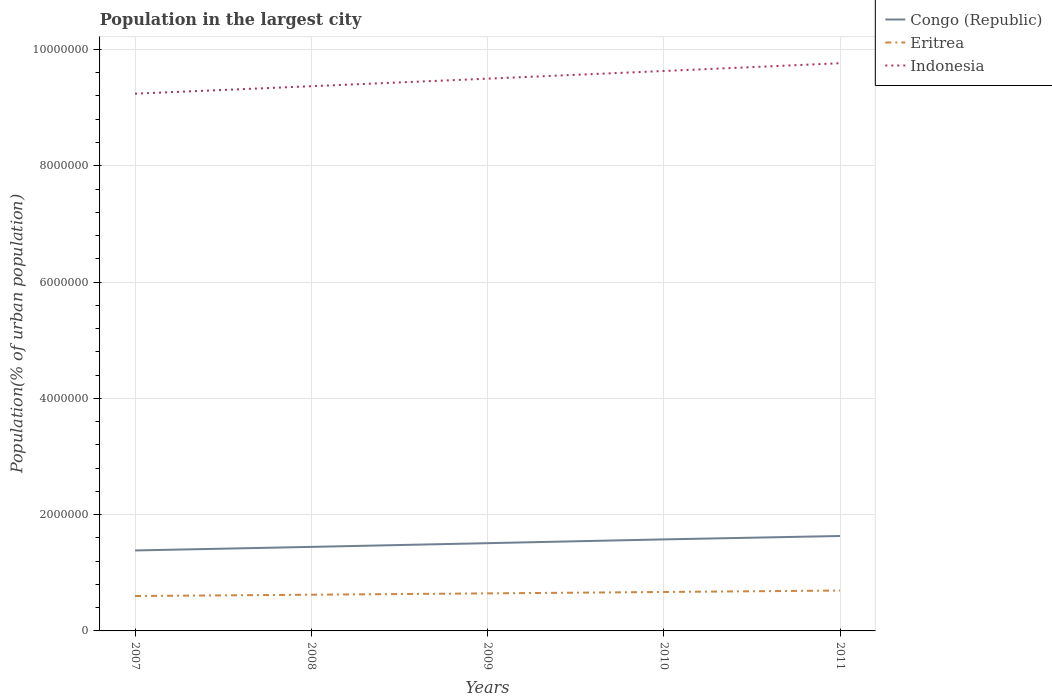Does the line corresponding to Congo (Republic) intersect with the line corresponding to Indonesia?
Provide a succinct answer. No. Across all years, what is the maximum population in the largest city in Congo (Republic)?
Provide a short and direct response. 1.38e+06. What is the total population in the largest city in Congo (Republic) in the graph?
Keep it short and to the point. -1.87e+05. What is the difference between the highest and the second highest population in the largest city in Indonesia?
Your answer should be very brief. 5.24e+05. How many lines are there?
Give a very brief answer. 3. How many years are there in the graph?
Provide a short and direct response. 5. What is the difference between two consecutive major ticks on the Y-axis?
Make the answer very short. 2.00e+06. Are the values on the major ticks of Y-axis written in scientific E-notation?
Give a very brief answer. No. Does the graph contain any zero values?
Offer a terse response. No. Where does the legend appear in the graph?
Provide a short and direct response. Top right. How many legend labels are there?
Your answer should be very brief. 3. What is the title of the graph?
Offer a very short reply. Population in the largest city. Does "Albania" appear as one of the legend labels in the graph?
Make the answer very short. No. What is the label or title of the Y-axis?
Provide a succinct answer. Population(% of urban population). What is the Population(% of urban population) in Congo (Republic) in 2007?
Your answer should be very brief. 1.38e+06. What is the Population(% of urban population) in Eritrea in 2007?
Give a very brief answer. 6.00e+05. What is the Population(% of urban population) in Indonesia in 2007?
Your response must be concise. 9.24e+06. What is the Population(% of urban population) in Congo (Republic) in 2008?
Your response must be concise. 1.45e+06. What is the Population(% of urban population) of Eritrea in 2008?
Your answer should be compact. 6.23e+05. What is the Population(% of urban population) in Indonesia in 2008?
Provide a succinct answer. 9.37e+06. What is the Population(% of urban population) in Congo (Republic) in 2009?
Ensure brevity in your answer.  1.51e+06. What is the Population(% of urban population) in Eritrea in 2009?
Your answer should be compact. 6.46e+05. What is the Population(% of urban population) in Indonesia in 2009?
Offer a terse response. 9.50e+06. What is the Population(% of urban population) of Congo (Republic) in 2010?
Your response must be concise. 1.57e+06. What is the Population(% of urban population) in Eritrea in 2010?
Your response must be concise. 6.70e+05. What is the Population(% of urban population) in Indonesia in 2010?
Keep it short and to the point. 9.63e+06. What is the Population(% of urban population) in Congo (Republic) in 2011?
Make the answer very short. 1.63e+06. What is the Population(% of urban population) in Eritrea in 2011?
Ensure brevity in your answer.  6.94e+05. What is the Population(% of urban population) in Indonesia in 2011?
Offer a terse response. 9.76e+06. Across all years, what is the maximum Population(% of urban population) in Congo (Republic)?
Your response must be concise. 1.63e+06. Across all years, what is the maximum Population(% of urban population) of Eritrea?
Offer a terse response. 6.94e+05. Across all years, what is the maximum Population(% of urban population) in Indonesia?
Offer a very short reply. 9.76e+06. Across all years, what is the minimum Population(% of urban population) of Congo (Republic)?
Keep it short and to the point. 1.38e+06. Across all years, what is the minimum Population(% of urban population) of Eritrea?
Ensure brevity in your answer.  6.00e+05. Across all years, what is the minimum Population(% of urban population) in Indonesia?
Give a very brief answer. 9.24e+06. What is the total Population(% of urban population) in Congo (Republic) in the graph?
Keep it short and to the point. 7.54e+06. What is the total Population(% of urban population) of Eritrea in the graph?
Provide a short and direct response. 3.23e+06. What is the total Population(% of urban population) in Indonesia in the graph?
Your answer should be compact. 4.75e+07. What is the difference between the Population(% of urban population) in Congo (Republic) in 2007 and that in 2008?
Ensure brevity in your answer.  -6.13e+04. What is the difference between the Population(% of urban population) of Eritrea in 2007 and that in 2008?
Offer a terse response. -2.22e+04. What is the difference between the Population(% of urban population) in Indonesia in 2007 and that in 2008?
Keep it short and to the point. -1.28e+05. What is the difference between the Population(% of urban population) in Congo (Republic) in 2007 and that in 2009?
Ensure brevity in your answer.  -1.25e+05. What is the difference between the Population(% of urban population) in Eritrea in 2007 and that in 2009?
Provide a succinct answer. -4.53e+04. What is the difference between the Population(% of urban population) of Indonesia in 2007 and that in 2009?
Provide a short and direct response. -2.58e+05. What is the difference between the Population(% of urban population) of Congo (Republic) in 2007 and that in 2010?
Provide a short and direct response. -1.90e+05. What is the difference between the Population(% of urban population) of Eritrea in 2007 and that in 2010?
Keep it short and to the point. -6.92e+04. What is the difference between the Population(% of urban population) of Indonesia in 2007 and that in 2010?
Offer a very short reply. -3.90e+05. What is the difference between the Population(% of urban population) of Congo (Republic) in 2007 and that in 2011?
Your response must be concise. -2.49e+05. What is the difference between the Population(% of urban population) in Eritrea in 2007 and that in 2011?
Your answer should be compact. -9.40e+04. What is the difference between the Population(% of urban population) of Indonesia in 2007 and that in 2011?
Your response must be concise. -5.24e+05. What is the difference between the Population(% of urban population) of Congo (Republic) in 2008 and that in 2009?
Offer a terse response. -6.40e+04. What is the difference between the Population(% of urban population) in Eritrea in 2008 and that in 2009?
Offer a very short reply. -2.31e+04. What is the difference between the Population(% of urban population) in Indonesia in 2008 and that in 2009?
Your response must be concise. -1.30e+05. What is the difference between the Population(% of urban population) in Congo (Republic) in 2008 and that in 2010?
Your answer should be compact. -1.29e+05. What is the difference between the Population(% of urban population) of Eritrea in 2008 and that in 2010?
Offer a very short reply. -4.70e+04. What is the difference between the Population(% of urban population) in Indonesia in 2008 and that in 2010?
Keep it short and to the point. -2.62e+05. What is the difference between the Population(% of urban population) in Congo (Republic) in 2008 and that in 2011?
Your response must be concise. -1.87e+05. What is the difference between the Population(% of urban population) in Eritrea in 2008 and that in 2011?
Offer a very short reply. -7.18e+04. What is the difference between the Population(% of urban population) in Indonesia in 2008 and that in 2011?
Ensure brevity in your answer.  -3.95e+05. What is the difference between the Population(% of urban population) of Congo (Republic) in 2009 and that in 2010?
Provide a succinct answer. -6.49e+04. What is the difference between the Population(% of urban population) in Eritrea in 2009 and that in 2010?
Your answer should be compact. -2.39e+04. What is the difference between the Population(% of urban population) of Indonesia in 2009 and that in 2010?
Ensure brevity in your answer.  -1.32e+05. What is the difference between the Population(% of urban population) of Congo (Republic) in 2009 and that in 2011?
Your answer should be compact. -1.23e+05. What is the difference between the Population(% of urban population) of Eritrea in 2009 and that in 2011?
Your answer should be very brief. -4.87e+04. What is the difference between the Population(% of urban population) in Indonesia in 2009 and that in 2011?
Your answer should be compact. -2.66e+05. What is the difference between the Population(% of urban population) in Congo (Republic) in 2010 and that in 2011?
Your response must be concise. -5.84e+04. What is the difference between the Population(% of urban population) of Eritrea in 2010 and that in 2011?
Provide a succinct answer. -2.48e+04. What is the difference between the Population(% of urban population) in Indonesia in 2010 and that in 2011?
Make the answer very short. -1.34e+05. What is the difference between the Population(% of urban population) of Congo (Republic) in 2007 and the Population(% of urban population) of Eritrea in 2008?
Your response must be concise. 7.61e+05. What is the difference between the Population(% of urban population) in Congo (Republic) in 2007 and the Population(% of urban population) in Indonesia in 2008?
Provide a succinct answer. -7.98e+06. What is the difference between the Population(% of urban population) in Eritrea in 2007 and the Population(% of urban population) in Indonesia in 2008?
Give a very brief answer. -8.77e+06. What is the difference between the Population(% of urban population) in Congo (Republic) in 2007 and the Population(% of urban population) in Eritrea in 2009?
Ensure brevity in your answer.  7.38e+05. What is the difference between the Population(% of urban population) of Congo (Republic) in 2007 and the Population(% of urban population) of Indonesia in 2009?
Provide a succinct answer. -8.11e+06. What is the difference between the Population(% of urban population) in Eritrea in 2007 and the Population(% of urban population) in Indonesia in 2009?
Give a very brief answer. -8.90e+06. What is the difference between the Population(% of urban population) of Congo (Republic) in 2007 and the Population(% of urban population) of Eritrea in 2010?
Make the answer very short. 7.14e+05. What is the difference between the Population(% of urban population) of Congo (Republic) in 2007 and the Population(% of urban population) of Indonesia in 2010?
Your answer should be compact. -8.25e+06. What is the difference between the Population(% of urban population) in Eritrea in 2007 and the Population(% of urban population) in Indonesia in 2010?
Offer a terse response. -9.03e+06. What is the difference between the Population(% of urban population) of Congo (Republic) in 2007 and the Population(% of urban population) of Eritrea in 2011?
Give a very brief answer. 6.89e+05. What is the difference between the Population(% of urban population) in Congo (Republic) in 2007 and the Population(% of urban population) in Indonesia in 2011?
Ensure brevity in your answer.  -8.38e+06. What is the difference between the Population(% of urban population) in Eritrea in 2007 and the Population(% of urban population) in Indonesia in 2011?
Your answer should be compact. -9.16e+06. What is the difference between the Population(% of urban population) of Congo (Republic) in 2008 and the Population(% of urban population) of Eritrea in 2009?
Make the answer very short. 7.99e+05. What is the difference between the Population(% of urban population) in Congo (Republic) in 2008 and the Population(% of urban population) in Indonesia in 2009?
Keep it short and to the point. -8.05e+06. What is the difference between the Population(% of urban population) of Eritrea in 2008 and the Population(% of urban population) of Indonesia in 2009?
Offer a terse response. -8.88e+06. What is the difference between the Population(% of urban population) of Congo (Republic) in 2008 and the Population(% of urban population) of Eritrea in 2010?
Offer a terse response. 7.76e+05. What is the difference between the Population(% of urban population) in Congo (Republic) in 2008 and the Population(% of urban population) in Indonesia in 2010?
Offer a terse response. -8.18e+06. What is the difference between the Population(% of urban population) in Eritrea in 2008 and the Population(% of urban population) in Indonesia in 2010?
Offer a very short reply. -9.01e+06. What is the difference between the Population(% of urban population) in Congo (Republic) in 2008 and the Population(% of urban population) in Eritrea in 2011?
Keep it short and to the point. 7.51e+05. What is the difference between the Population(% of urban population) of Congo (Republic) in 2008 and the Population(% of urban population) of Indonesia in 2011?
Your answer should be very brief. -8.32e+06. What is the difference between the Population(% of urban population) in Eritrea in 2008 and the Population(% of urban population) in Indonesia in 2011?
Provide a short and direct response. -9.14e+06. What is the difference between the Population(% of urban population) of Congo (Republic) in 2009 and the Population(% of urban population) of Eritrea in 2010?
Offer a terse response. 8.40e+05. What is the difference between the Population(% of urban population) of Congo (Republic) in 2009 and the Population(% of urban population) of Indonesia in 2010?
Provide a short and direct response. -8.12e+06. What is the difference between the Population(% of urban population) of Eritrea in 2009 and the Population(% of urban population) of Indonesia in 2010?
Your answer should be compact. -8.98e+06. What is the difference between the Population(% of urban population) of Congo (Republic) in 2009 and the Population(% of urban population) of Eritrea in 2011?
Make the answer very short. 8.15e+05. What is the difference between the Population(% of urban population) of Congo (Republic) in 2009 and the Population(% of urban population) of Indonesia in 2011?
Ensure brevity in your answer.  -8.25e+06. What is the difference between the Population(% of urban population) of Eritrea in 2009 and the Population(% of urban population) of Indonesia in 2011?
Provide a short and direct response. -9.12e+06. What is the difference between the Population(% of urban population) in Congo (Republic) in 2010 and the Population(% of urban population) in Eritrea in 2011?
Your answer should be compact. 8.80e+05. What is the difference between the Population(% of urban population) of Congo (Republic) in 2010 and the Population(% of urban population) of Indonesia in 2011?
Provide a succinct answer. -8.19e+06. What is the difference between the Population(% of urban population) in Eritrea in 2010 and the Population(% of urban population) in Indonesia in 2011?
Provide a short and direct response. -9.09e+06. What is the average Population(% of urban population) in Congo (Republic) per year?
Make the answer very short. 1.51e+06. What is the average Population(% of urban population) of Eritrea per year?
Ensure brevity in your answer.  6.47e+05. What is the average Population(% of urban population) of Indonesia per year?
Provide a succinct answer. 9.50e+06. In the year 2007, what is the difference between the Population(% of urban population) of Congo (Republic) and Population(% of urban population) of Eritrea?
Offer a very short reply. 7.83e+05. In the year 2007, what is the difference between the Population(% of urban population) in Congo (Republic) and Population(% of urban population) in Indonesia?
Keep it short and to the point. -7.86e+06. In the year 2007, what is the difference between the Population(% of urban population) in Eritrea and Population(% of urban population) in Indonesia?
Offer a very short reply. -8.64e+06. In the year 2008, what is the difference between the Population(% of urban population) of Congo (Republic) and Population(% of urban population) of Eritrea?
Make the answer very short. 8.22e+05. In the year 2008, what is the difference between the Population(% of urban population) in Congo (Republic) and Population(% of urban population) in Indonesia?
Your response must be concise. -7.92e+06. In the year 2008, what is the difference between the Population(% of urban population) of Eritrea and Population(% of urban population) of Indonesia?
Your answer should be very brief. -8.75e+06. In the year 2009, what is the difference between the Population(% of urban population) in Congo (Republic) and Population(% of urban population) in Eritrea?
Offer a very short reply. 8.63e+05. In the year 2009, what is the difference between the Population(% of urban population) in Congo (Republic) and Population(% of urban population) in Indonesia?
Ensure brevity in your answer.  -7.99e+06. In the year 2009, what is the difference between the Population(% of urban population) in Eritrea and Population(% of urban population) in Indonesia?
Your response must be concise. -8.85e+06. In the year 2010, what is the difference between the Population(% of urban population) in Congo (Republic) and Population(% of urban population) in Eritrea?
Offer a very short reply. 9.04e+05. In the year 2010, what is the difference between the Population(% of urban population) of Congo (Republic) and Population(% of urban population) of Indonesia?
Keep it short and to the point. -8.06e+06. In the year 2010, what is the difference between the Population(% of urban population) in Eritrea and Population(% of urban population) in Indonesia?
Provide a succinct answer. -8.96e+06. In the year 2011, what is the difference between the Population(% of urban population) of Congo (Republic) and Population(% of urban population) of Eritrea?
Ensure brevity in your answer.  9.38e+05. In the year 2011, what is the difference between the Population(% of urban population) of Congo (Republic) and Population(% of urban population) of Indonesia?
Offer a very short reply. -8.13e+06. In the year 2011, what is the difference between the Population(% of urban population) of Eritrea and Population(% of urban population) of Indonesia?
Make the answer very short. -9.07e+06. What is the ratio of the Population(% of urban population) in Congo (Republic) in 2007 to that in 2008?
Make the answer very short. 0.96. What is the ratio of the Population(% of urban population) of Eritrea in 2007 to that in 2008?
Your answer should be very brief. 0.96. What is the ratio of the Population(% of urban population) of Indonesia in 2007 to that in 2008?
Your answer should be compact. 0.99. What is the ratio of the Population(% of urban population) in Congo (Republic) in 2007 to that in 2009?
Provide a succinct answer. 0.92. What is the ratio of the Population(% of urban population) in Eritrea in 2007 to that in 2009?
Give a very brief answer. 0.93. What is the ratio of the Population(% of urban population) of Indonesia in 2007 to that in 2009?
Your response must be concise. 0.97. What is the ratio of the Population(% of urban population) in Congo (Republic) in 2007 to that in 2010?
Provide a succinct answer. 0.88. What is the ratio of the Population(% of urban population) in Eritrea in 2007 to that in 2010?
Your answer should be very brief. 0.9. What is the ratio of the Population(% of urban population) of Indonesia in 2007 to that in 2010?
Your answer should be compact. 0.96. What is the ratio of the Population(% of urban population) in Congo (Republic) in 2007 to that in 2011?
Provide a short and direct response. 0.85. What is the ratio of the Population(% of urban population) in Eritrea in 2007 to that in 2011?
Give a very brief answer. 0.86. What is the ratio of the Population(% of urban population) of Indonesia in 2007 to that in 2011?
Your answer should be very brief. 0.95. What is the ratio of the Population(% of urban population) in Congo (Republic) in 2008 to that in 2009?
Provide a short and direct response. 0.96. What is the ratio of the Population(% of urban population) in Eritrea in 2008 to that in 2009?
Give a very brief answer. 0.96. What is the ratio of the Population(% of urban population) of Indonesia in 2008 to that in 2009?
Keep it short and to the point. 0.99. What is the ratio of the Population(% of urban population) in Congo (Republic) in 2008 to that in 2010?
Offer a very short reply. 0.92. What is the ratio of the Population(% of urban population) of Eritrea in 2008 to that in 2010?
Give a very brief answer. 0.93. What is the ratio of the Population(% of urban population) of Indonesia in 2008 to that in 2010?
Give a very brief answer. 0.97. What is the ratio of the Population(% of urban population) in Congo (Republic) in 2008 to that in 2011?
Provide a succinct answer. 0.89. What is the ratio of the Population(% of urban population) of Eritrea in 2008 to that in 2011?
Offer a terse response. 0.9. What is the ratio of the Population(% of urban population) in Indonesia in 2008 to that in 2011?
Ensure brevity in your answer.  0.96. What is the ratio of the Population(% of urban population) of Congo (Republic) in 2009 to that in 2010?
Offer a terse response. 0.96. What is the ratio of the Population(% of urban population) in Eritrea in 2009 to that in 2010?
Provide a short and direct response. 0.96. What is the ratio of the Population(% of urban population) in Indonesia in 2009 to that in 2010?
Offer a terse response. 0.99. What is the ratio of the Population(% of urban population) of Congo (Republic) in 2009 to that in 2011?
Offer a terse response. 0.92. What is the ratio of the Population(% of urban population) in Eritrea in 2009 to that in 2011?
Provide a succinct answer. 0.93. What is the ratio of the Population(% of urban population) of Indonesia in 2009 to that in 2011?
Make the answer very short. 0.97. What is the ratio of the Population(% of urban population) of Congo (Republic) in 2010 to that in 2011?
Provide a succinct answer. 0.96. What is the ratio of the Population(% of urban population) in Indonesia in 2010 to that in 2011?
Provide a succinct answer. 0.99. What is the difference between the highest and the second highest Population(% of urban population) of Congo (Republic)?
Provide a succinct answer. 5.84e+04. What is the difference between the highest and the second highest Population(% of urban population) in Eritrea?
Ensure brevity in your answer.  2.48e+04. What is the difference between the highest and the second highest Population(% of urban population) in Indonesia?
Keep it short and to the point. 1.34e+05. What is the difference between the highest and the lowest Population(% of urban population) of Congo (Republic)?
Make the answer very short. 2.49e+05. What is the difference between the highest and the lowest Population(% of urban population) in Eritrea?
Make the answer very short. 9.40e+04. What is the difference between the highest and the lowest Population(% of urban population) in Indonesia?
Ensure brevity in your answer.  5.24e+05. 